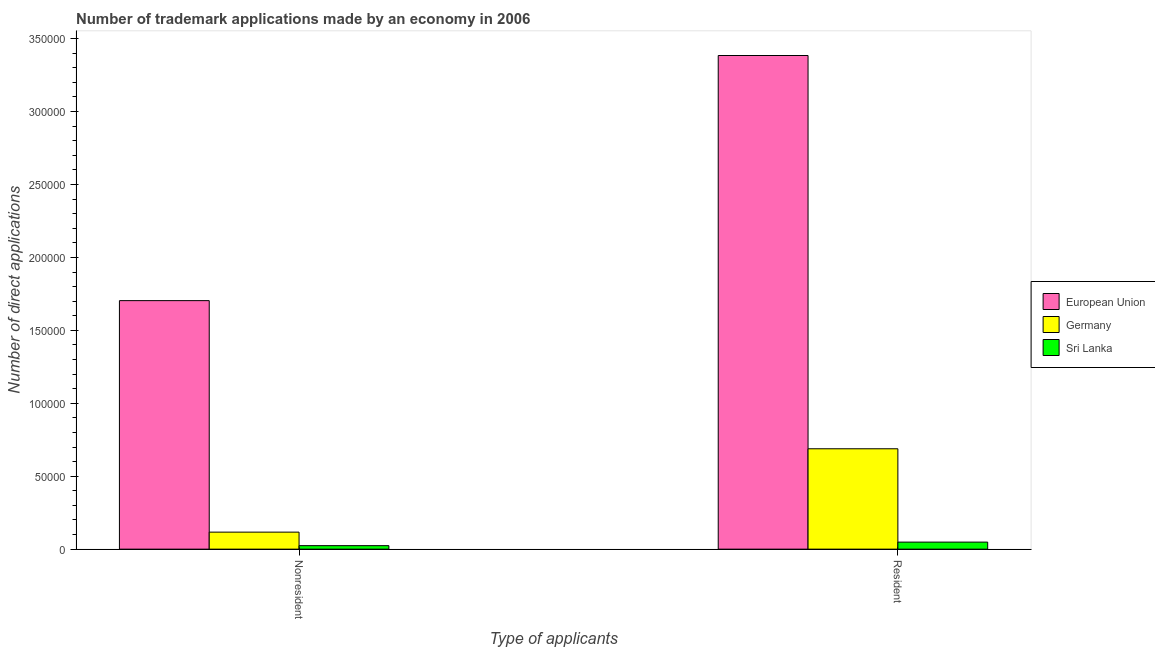How many different coloured bars are there?
Your answer should be compact. 3. How many bars are there on the 2nd tick from the left?
Offer a terse response. 3. What is the label of the 1st group of bars from the left?
Your response must be concise. Nonresident. What is the number of trademark applications made by non residents in Sri Lanka?
Provide a succinct answer. 2392. Across all countries, what is the maximum number of trademark applications made by residents?
Offer a terse response. 3.38e+05. Across all countries, what is the minimum number of trademark applications made by non residents?
Your response must be concise. 2392. In which country was the number of trademark applications made by residents maximum?
Your response must be concise. European Union. In which country was the number of trademark applications made by non residents minimum?
Offer a very short reply. Sri Lanka. What is the total number of trademark applications made by residents in the graph?
Offer a terse response. 4.12e+05. What is the difference between the number of trademark applications made by non residents in Germany and that in European Union?
Your answer should be compact. -1.59e+05. What is the difference between the number of trademark applications made by non residents in Germany and the number of trademark applications made by residents in Sri Lanka?
Provide a short and direct response. 6843. What is the average number of trademark applications made by residents per country?
Offer a very short reply. 1.37e+05. What is the difference between the number of trademark applications made by residents and number of trademark applications made by non residents in European Union?
Keep it short and to the point. 1.68e+05. In how many countries, is the number of trademark applications made by residents greater than 230000 ?
Your response must be concise. 1. What is the ratio of the number of trademark applications made by residents in European Union to that in Sri Lanka?
Provide a succinct answer. 70.2. Are the values on the major ticks of Y-axis written in scientific E-notation?
Provide a short and direct response. No. Does the graph contain any zero values?
Give a very brief answer. No. Where does the legend appear in the graph?
Make the answer very short. Center right. How many legend labels are there?
Make the answer very short. 3. What is the title of the graph?
Provide a short and direct response. Number of trademark applications made by an economy in 2006. Does "Sierra Leone" appear as one of the legend labels in the graph?
Offer a very short reply. No. What is the label or title of the X-axis?
Your answer should be very brief. Type of applicants. What is the label or title of the Y-axis?
Provide a succinct answer. Number of direct applications. What is the Number of direct applications of European Union in Nonresident?
Offer a terse response. 1.70e+05. What is the Number of direct applications in Germany in Nonresident?
Ensure brevity in your answer.  1.17e+04. What is the Number of direct applications of Sri Lanka in Nonresident?
Provide a succinct answer. 2392. What is the Number of direct applications in European Union in Resident?
Ensure brevity in your answer.  3.38e+05. What is the Number of direct applications of Germany in Resident?
Your answer should be very brief. 6.88e+04. What is the Number of direct applications in Sri Lanka in Resident?
Offer a terse response. 4821. Across all Type of applicants, what is the maximum Number of direct applications of European Union?
Your response must be concise. 3.38e+05. Across all Type of applicants, what is the maximum Number of direct applications of Germany?
Make the answer very short. 6.88e+04. Across all Type of applicants, what is the maximum Number of direct applications in Sri Lanka?
Offer a very short reply. 4821. Across all Type of applicants, what is the minimum Number of direct applications in European Union?
Provide a succinct answer. 1.70e+05. Across all Type of applicants, what is the minimum Number of direct applications of Germany?
Provide a succinct answer. 1.17e+04. Across all Type of applicants, what is the minimum Number of direct applications in Sri Lanka?
Keep it short and to the point. 2392. What is the total Number of direct applications in European Union in the graph?
Keep it short and to the point. 5.09e+05. What is the total Number of direct applications of Germany in the graph?
Your answer should be very brief. 8.05e+04. What is the total Number of direct applications of Sri Lanka in the graph?
Provide a succinct answer. 7213. What is the difference between the Number of direct applications of European Union in Nonresident and that in Resident?
Provide a short and direct response. -1.68e+05. What is the difference between the Number of direct applications of Germany in Nonresident and that in Resident?
Your response must be concise. -5.72e+04. What is the difference between the Number of direct applications of Sri Lanka in Nonresident and that in Resident?
Keep it short and to the point. -2429. What is the difference between the Number of direct applications of European Union in Nonresident and the Number of direct applications of Germany in Resident?
Provide a succinct answer. 1.02e+05. What is the difference between the Number of direct applications in European Union in Nonresident and the Number of direct applications in Sri Lanka in Resident?
Keep it short and to the point. 1.66e+05. What is the difference between the Number of direct applications in Germany in Nonresident and the Number of direct applications in Sri Lanka in Resident?
Give a very brief answer. 6843. What is the average Number of direct applications in European Union per Type of applicants?
Your response must be concise. 2.54e+05. What is the average Number of direct applications of Germany per Type of applicants?
Provide a succinct answer. 4.02e+04. What is the average Number of direct applications of Sri Lanka per Type of applicants?
Your response must be concise. 3606.5. What is the difference between the Number of direct applications in European Union and Number of direct applications in Germany in Nonresident?
Offer a terse response. 1.59e+05. What is the difference between the Number of direct applications of European Union and Number of direct applications of Sri Lanka in Nonresident?
Your response must be concise. 1.68e+05. What is the difference between the Number of direct applications in Germany and Number of direct applications in Sri Lanka in Nonresident?
Provide a succinct answer. 9272. What is the difference between the Number of direct applications in European Union and Number of direct applications in Germany in Resident?
Keep it short and to the point. 2.70e+05. What is the difference between the Number of direct applications in European Union and Number of direct applications in Sri Lanka in Resident?
Keep it short and to the point. 3.34e+05. What is the difference between the Number of direct applications in Germany and Number of direct applications in Sri Lanka in Resident?
Keep it short and to the point. 6.40e+04. What is the ratio of the Number of direct applications in European Union in Nonresident to that in Resident?
Make the answer very short. 0.5. What is the ratio of the Number of direct applications of Germany in Nonresident to that in Resident?
Provide a succinct answer. 0.17. What is the ratio of the Number of direct applications in Sri Lanka in Nonresident to that in Resident?
Offer a very short reply. 0.5. What is the difference between the highest and the second highest Number of direct applications of European Union?
Offer a terse response. 1.68e+05. What is the difference between the highest and the second highest Number of direct applications of Germany?
Give a very brief answer. 5.72e+04. What is the difference between the highest and the second highest Number of direct applications of Sri Lanka?
Provide a succinct answer. 2429. What is the difference between the highest and the lowest Number of direct applications in European Union?
Your answer should be very brief. 1.68e+05. What is the difference between the highest and the lowest Number of direct applications of Germany?
Make the answer very short. 5.72e+04. What is the difference between the highest and the lowest Number of direct applications in Sri Lanka?
Offer a very short reply. 2429. 